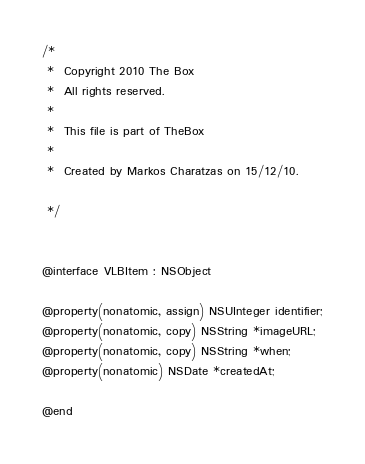Convert code to text. <code><loc_0><loc_0><loc_500><loc_500><_C_>/*
 *  Copyright 2010 The Box
 *  All rights reserved.
 *
 *  This file is part of TheBox
 *
 *  Created by Markos Charatzas on 15/12/10.

 */


@interface VLBItem : NSObject

@property(nonatomic, assign) NSUInteger identifier;
@property(nonatomic, copy) NSString *imageURL;
@property(nonatomic, copy) NSString *when;
@property(nonatomic) NSDate *createdAt;

@end
</code> 